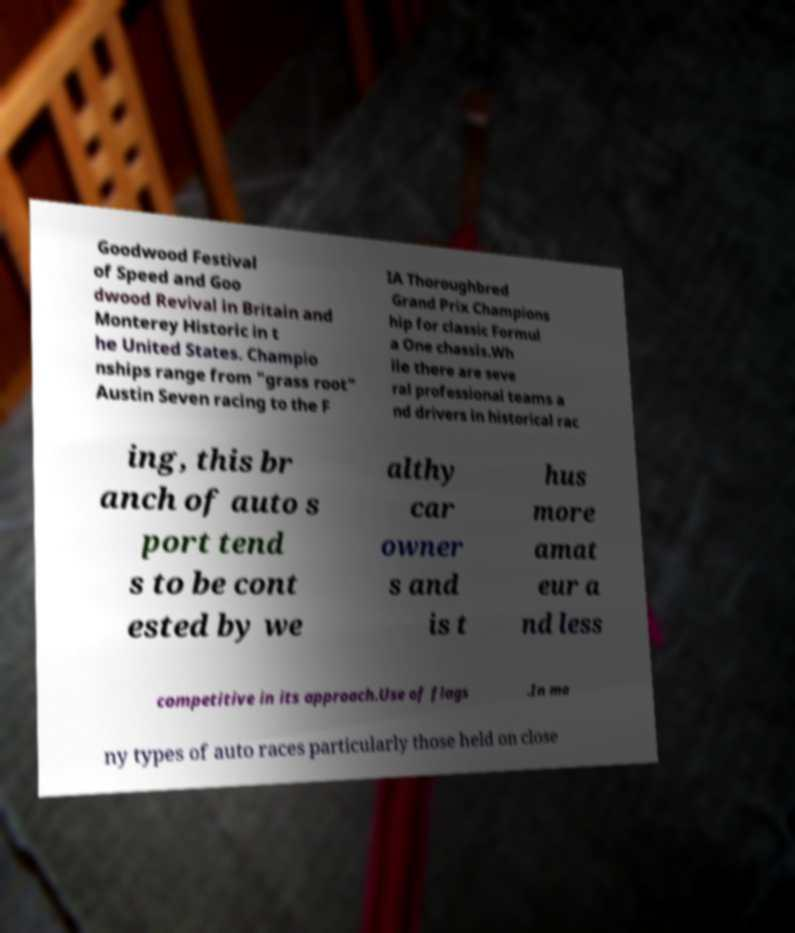Can you read and provide the text displayed in the image?This photo seems to have some interesting text. Can you extract and type it out for me? Goodwood Festival of Speed and Goo dwood Revival in Britain and Monterey Historic in t he United States. Champio nships range from "grass root" Austin Seven racing to the F IA Thoroughbred Grand Prix Champions hip for classic Formul a One chassis.Wh ile there are seve ral professional teams a nd drivers in historical rac ing, this br anch of auto s port tend s to be cont ested by we althy car owner s and is t hus more amat eur a nd less competitive in its approach.Use of flags .In ma ny types of auto races particularly those held on close 